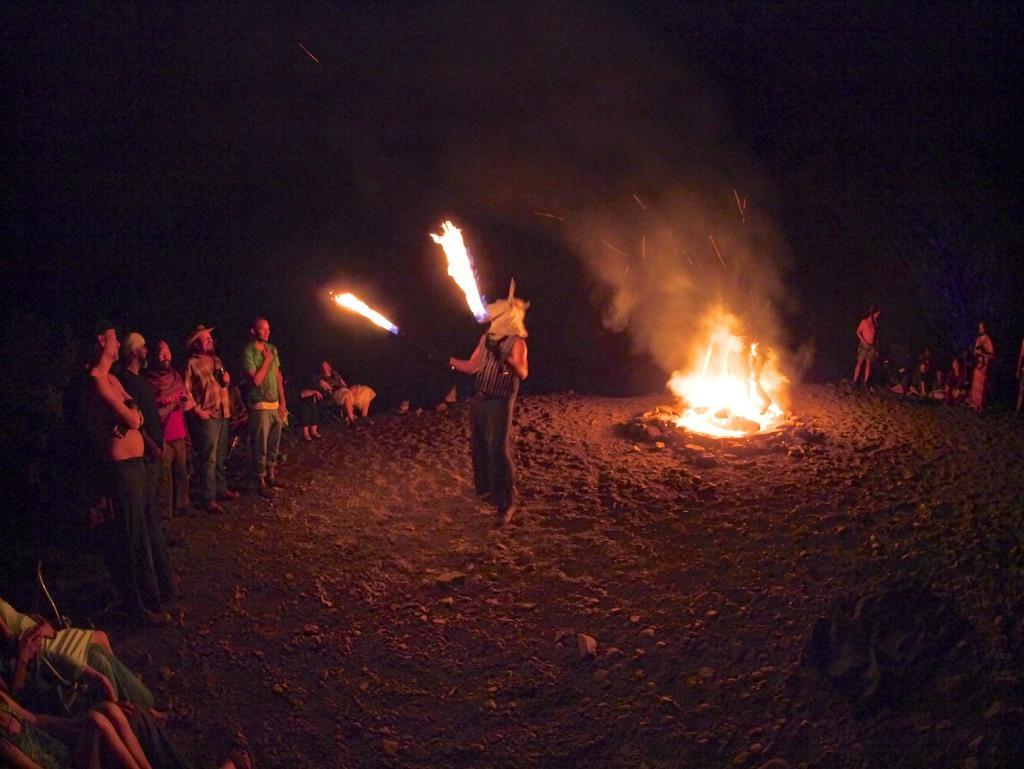Please provide a concise description of this image. In this image there is a person standing on the surface of the sand and he is holding an object, in which there is a fire, behind him there is a fire on the surface, around the person there are a few people standing and looking at him. The background is dark. 